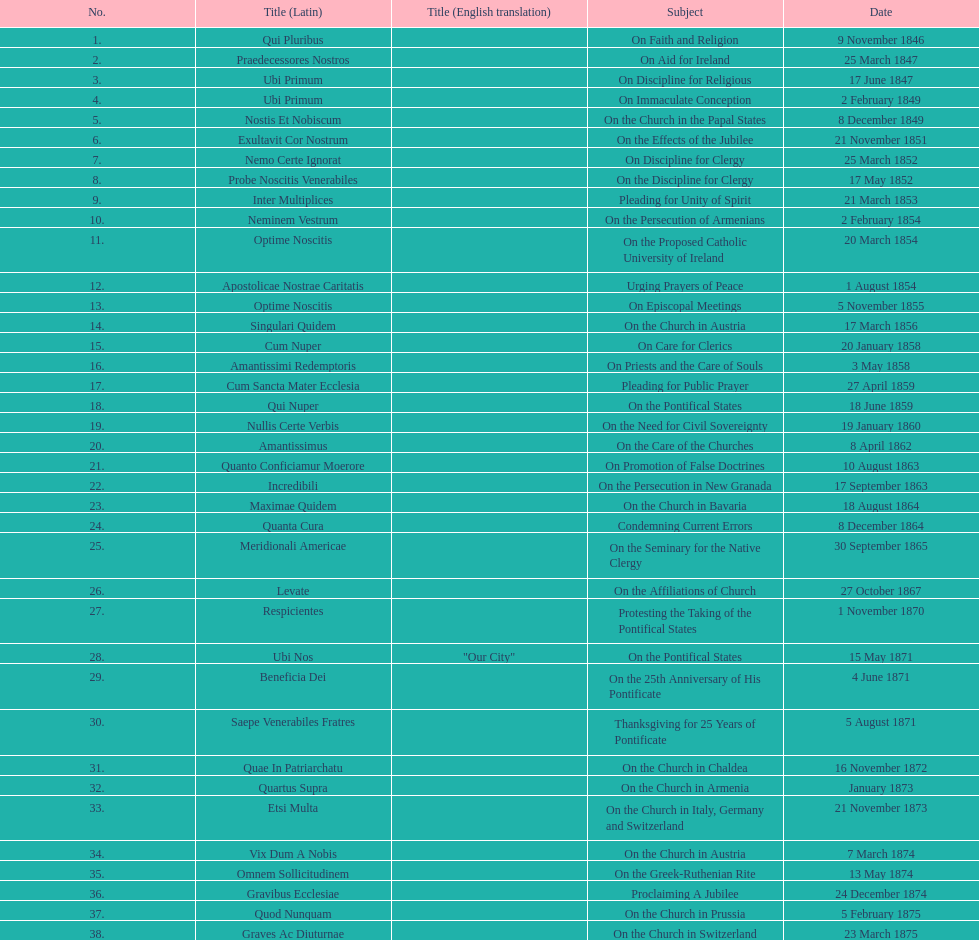How many encyclicals were issued between august 15, 1854 and october 26, 1867? 13. 